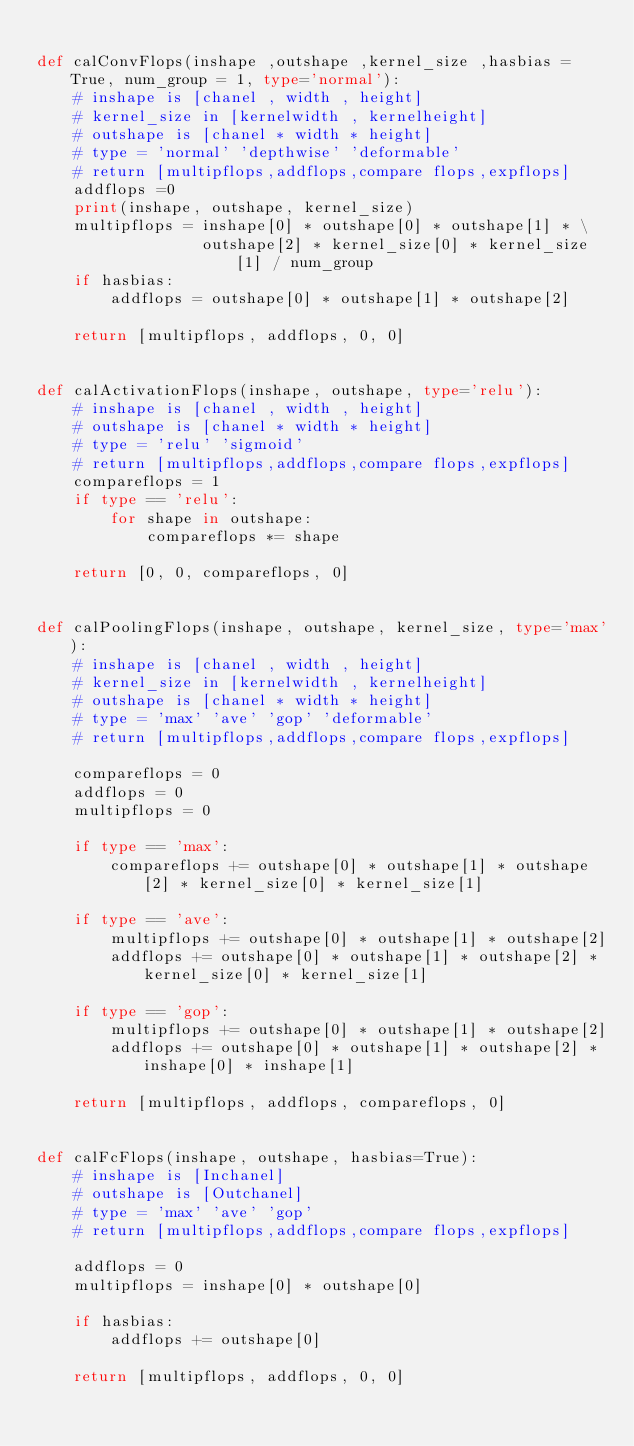Convert code to text. <code><loc_0><loc_0><loc_500><loc_500><_Python_>
def calConvFlops(inshape ,outshape ,kernel_size ,hasbias = True, num_group = 1, type='normal'):
    # inshape is [chanel , width , height]
    # kernel_size in [kernelwidth , kernelheight]
    # outshape is [chanel * width * height]
    # type = 'normal' 'depthwise' 'deformable'
    # return [multipflops,addflops,compare flops,expflops]
    addflops =0
    print(inshape, outshape, kernel_size)
    multipflops = inshape[0] * outshape[0] * outshape[1] * \
                  outshape[2] * kernel_size[0] * kernel_size[1] / num_group
    if hasbias:
        addflops = outshape[0] * outshape[1] * outshape[2]

    return [multipflops, addflops, 0, 0]


def calActivationFlops(inshape, outshape, type='relu'):
    # inshape is [chanel , width , height]
    # outshape is [chanel * width * height]
    # type = 'relu' 'sigmoid' 
    # return [multipflops,addflops,compare flops,expflops]
    compareflops = 1
    if type == 'relu':
        for shape in outshape:
            compareflops *= shape

    return [0, 0, compareflops, 0]


def calPoolingFlops(inshape, outshape, kernel_size, type='max'):
    # inshape is [chanel , width , height]
    # kernel_size in [kernelwidth , kernelheight]
    # outshape is [chanel * width * height]
    # type = 'max' 'ave' 'gop' 'deformable'
    # return [multipflops,addflops,compare flops,expflops]

    compareflops = 0
    addflops = 0
    multipflops = 0

    if type == 'max':
        compareflops += outshape[0] * outshape[1] * outshape[2] * kernel_size[0] * kernel_size[1]

    if type == 'ave':
        multipflops += outshape[0] * outshape[1] * outshape[2]
        addflops += outshape[0] * outshape[1] * outshape[2] * kernel_size[0] * kernel_size[1]

    if type == 'gop':
        multipflops += outshape[0] * outshape[1] * outshape[2]
        addflops += outshape[0] * outshape[1] * outshape[2] * inshape[0] * inshape[1]

    return [multipflops, addflops, compareflops, 0]


def calFcFlops(inshape, outshape, hasbias=True):
    # inshape is [Inchanel]
    # outshape is [Outchanel]
    # type = 'max' 'ave' 'gop'
    # return [multipflops,addflops,compare flops,expflops]

    addflops = 0
    multipflops = inshape[0] * outshape[0]

    if hasbias:
        addflops += outshape[0]

    return [multipflops, addflops, 0, 0]
</code> 